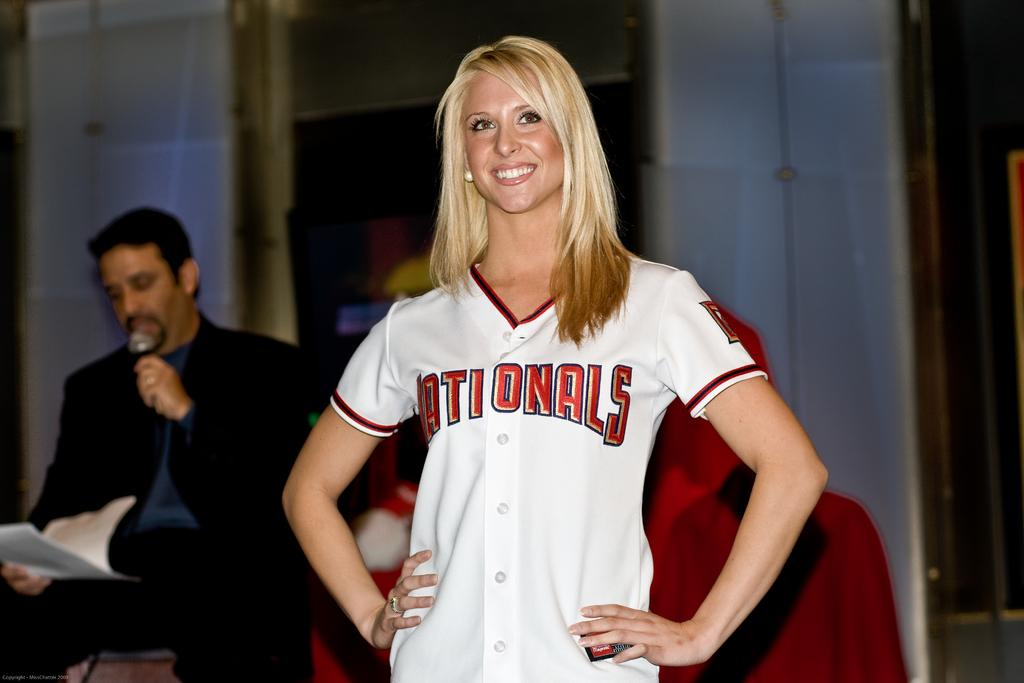<image>
Relay a brief, clear account of the picture shown. A blonde woman wears a jersey bearing the name Nationals. 